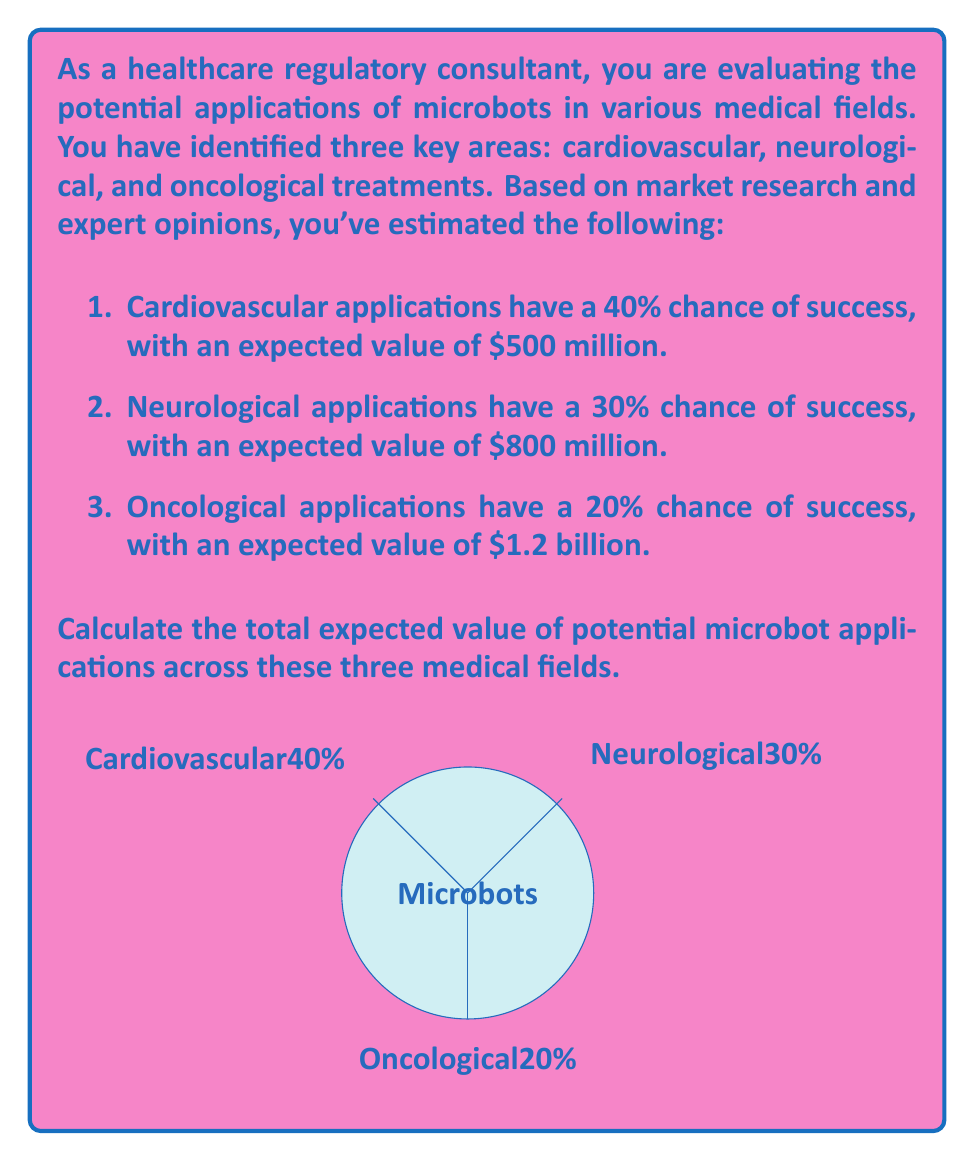Can you solve this math problem? To calculate the total expected value of potential microbot applications, we need to use the concept of expected value from decision theory. The expected value is calculated by multiplying the probability of success by the potential value for each application, then summing these values.

Let's break it down step-by-step:

1. Cardiovascular applications:
   Probability of success = 40% = 0.40
   Potential value = $500 million
   Expected value = $500 million × 0.40 = $200 million

2. Neurological applications:
   Probability of success = 30% = 0.30
   Potential value = $800 million
   Expected value = $800 million × 0.30 = $240 million

3. Oncological applications:
   Probability of success = 20% = 0.20
   Potential value = $1.2 billion = $1,200 million
   Expected value = $1,200 million × 0.20 = $240 million

Now, we sum up the expected values from all three applications:

Total Expected Value = $200 million + $240 million + $240 million = $680 million

We can express this mathematically as:

$$ \text{Total Expected Value} = \sum_{i=1}^{n} P(i) \times V(i) $$

Where:
$P(i)$ is the probability of success for application $i$
$V(i)$ is the potential value for application $i$
$n$ is the number of applications (in this case, 3)

$$ \text{Total Expected Value} = (0.40 \times \$500M) + (0.30 \times \$800M) + (0.20 \times \$1,200M) = \$680M $$
Answer: $680 million 